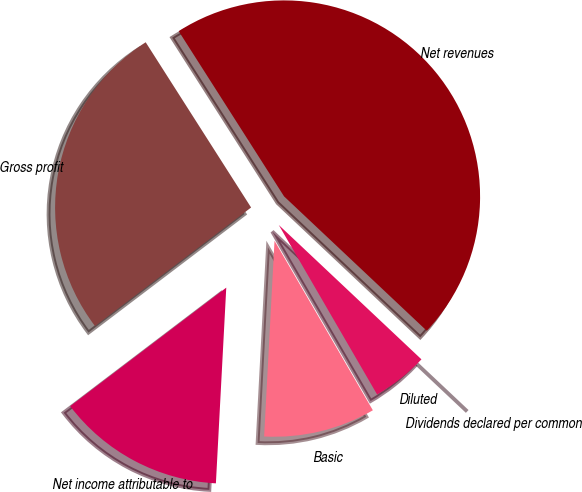Convert chart. <chart><loc_0><loc_0><loc_500><loc_500><pie_chart><fcel>Net revenues<fcel>Gross profit<fcel>Net income attributable to<fcel>Basic<fcel>Diluted<fcel>Dividends declared per common<nl><fcel>46.06%<fcel>26.3%<fcel>13.82%<fcel>9.21%<fcel>4.61%<fcel>0.0%<nl></chart> 